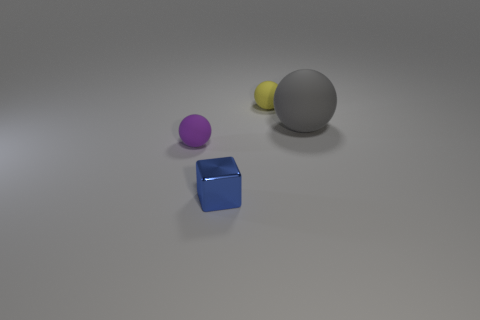If these objects were part of a physics study, what experiment could they be used for? These objects seem ideal for a study on the principles of geometry, density, and material properties. For instance, one could use them in an experiment to measure how different shapes and sizes affect rolling friction on a flat surface, or how light interacts with objects of various colors and textures. 